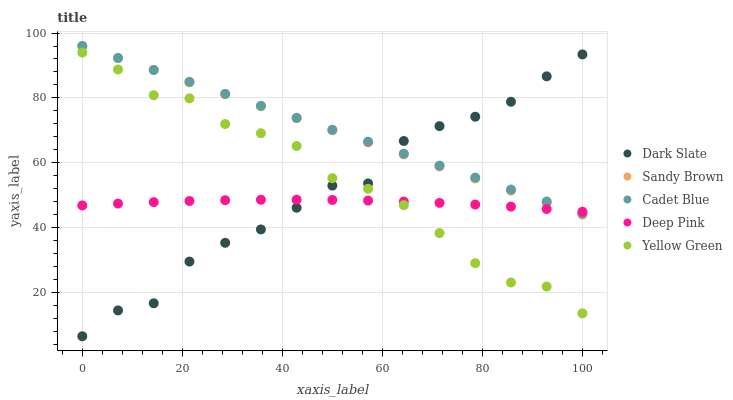Does Deep Pink have the minimum area under the curve?
Answer yes or no. Yes. Does Cadet Blue have the maximum area under the curve?
Answer yes or no. Yes. Does Sandy Brown have the minimum area under the curve?
Answer yes or no. No. Does Sandy Brown have the maximum area under the curve?
Answer yes or no. No. Is Sandy Brown the smoothest?
Answer yes or no. Yes. Is Dark Slate the roughest?
Answer yes or no. Yes. Is Cadet Blue the smoothest?
Answer yes or no. No. Is Cadet Blue the roughest?
Answer yes or no. No. Does Dark Slate have the lowest value?
Answer yes or no. Yes. Does Cadet Blue have the lowest value?
Answer yes or no. No. Does Sandy Brown have the highest value?
Answer yes or no. Yes. Does Yellow Green have the highest value?
Answer yes or no. No. Is Yellow Green less than Sandy Brown?
Answer yes or no. Yes. Is Cadet Blue greater than Yellow Green?
Answer yes or no. Yes. Does Dark Slate intersect Deep Pink?
Answer yes or no. Yes. Is Dark Slate less than Deep Pink?
Answer yes or no. No. Is Dark Slate greater than Deep Pink?
Answer yes or no. No. Does Yellow Green intersect Sandy Brown?
Answer yes or no. No. 